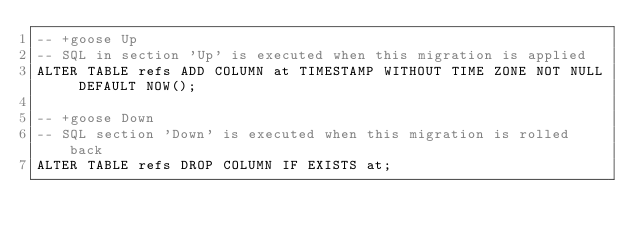Convert code to text. <code><loc_0><loc_0><loc_500><loc_500><_SQL_>-- +goose Up
-- SQL in section 'Up' is executed when this migration is applied
ALTER TABLE refs ADD COLUMN at TIMESTAMP WITHOUT TIME ZONE NOT NULL DEFAULT NOW();

-- +goose Down
-- SQL section 'Down' is executed when this migration is rolled back
ALTER TABLE refs DROP COLUMN IF EXISTS at;
</code> 